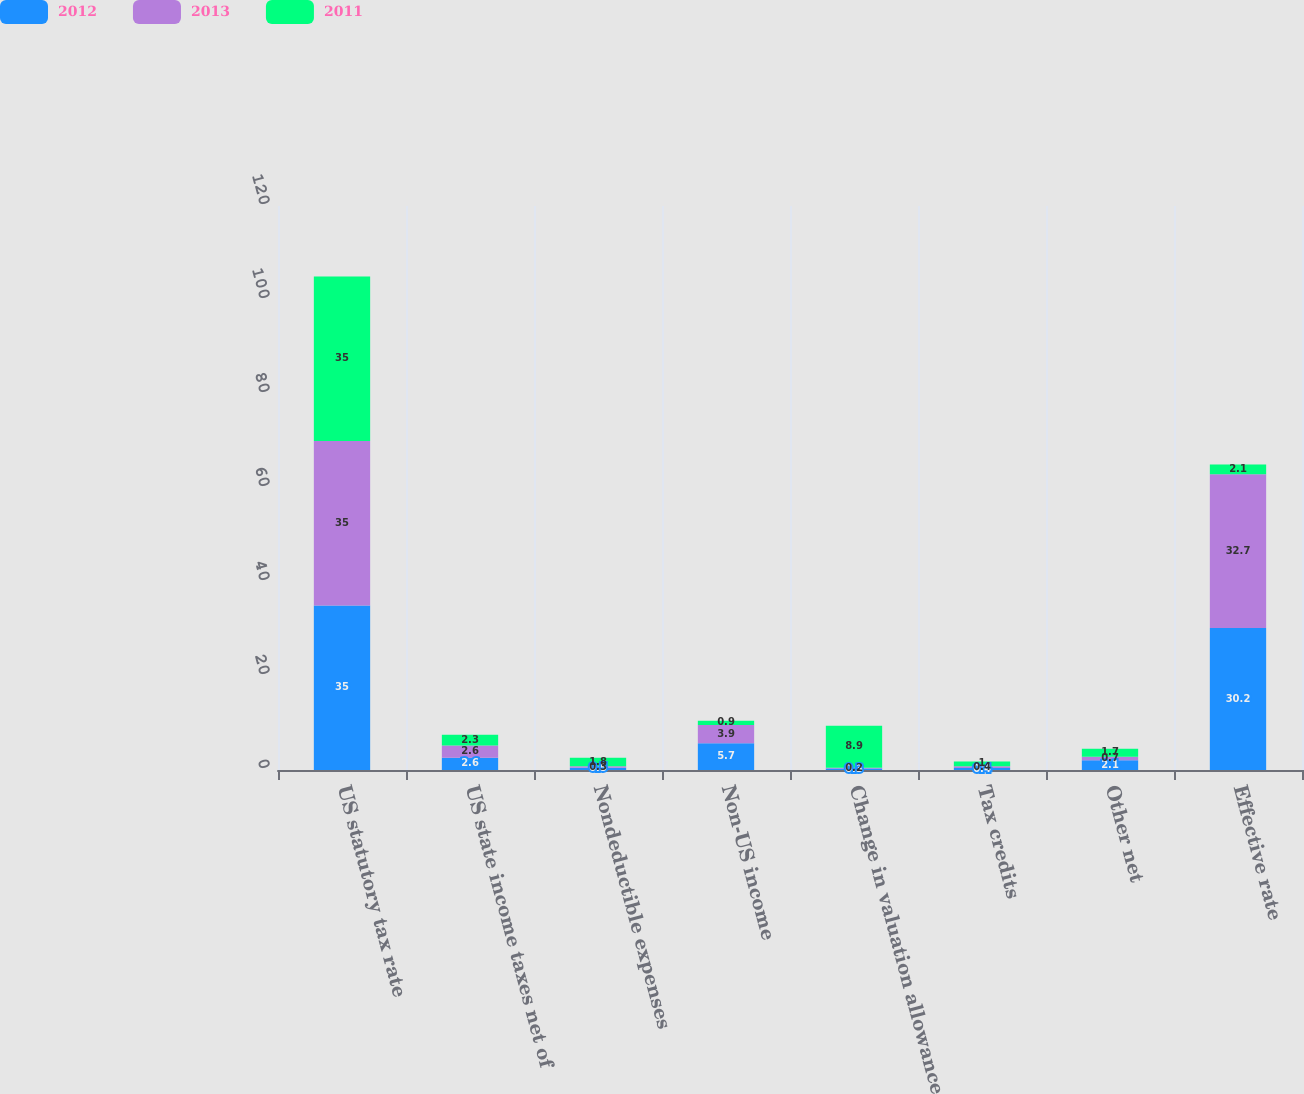Convert chart. <chart><loc_0><loc_0><loc_500><loc_500><stacked_bar_chart><ecel><fcel>US statutory tax rate<fcel>US state income taxes net of<fcel>Nondeductible expenses<fcel>Non-US income<fcel>Change in valuation allowance<fcel>Tax credits<fcel>Other net<fcel>Effective rate<nl><fcel>2012<fcel>35<fcel>2.6<fcel>0.5<fcel>5.7<fcel>0.3<fcel>0.4<fcel>2.1<fcel>30.2<nl><fcel>2013<fcel>35<fcel>2.6<fcel>0.3<fcel>3.9<fcel>0.2<fcel>0.4<fcel>0.7<fcel>32.7<nl><fcel>2011<fcel>35<fcel>2.3<fcel>1.8<fcel>0.9<fcel>8.9<fcel>1<fcel>1.7<fcel>2.1<nl></chart> 